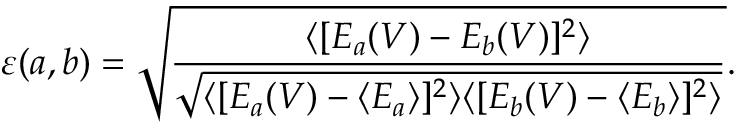Convert formula to latex. <formula><loc_0><loc_0><loc_500><loc_500>\varepsilon ( a , b ) = \sqrt { \frac { \langle [ E _ { a } ( V ) - E _ { b } ( V ) ] ^ { 2 } \rangle } { \sqrt { \langle [ E _ { a } ( V ) - \langle E _ { a } \rangle ] ^ { 2 } \rangle \langle [ E _ { b } ( V ) - \langle E _ { b } \rangle ] ^ { 2 } \rangle } } } .</formula> 